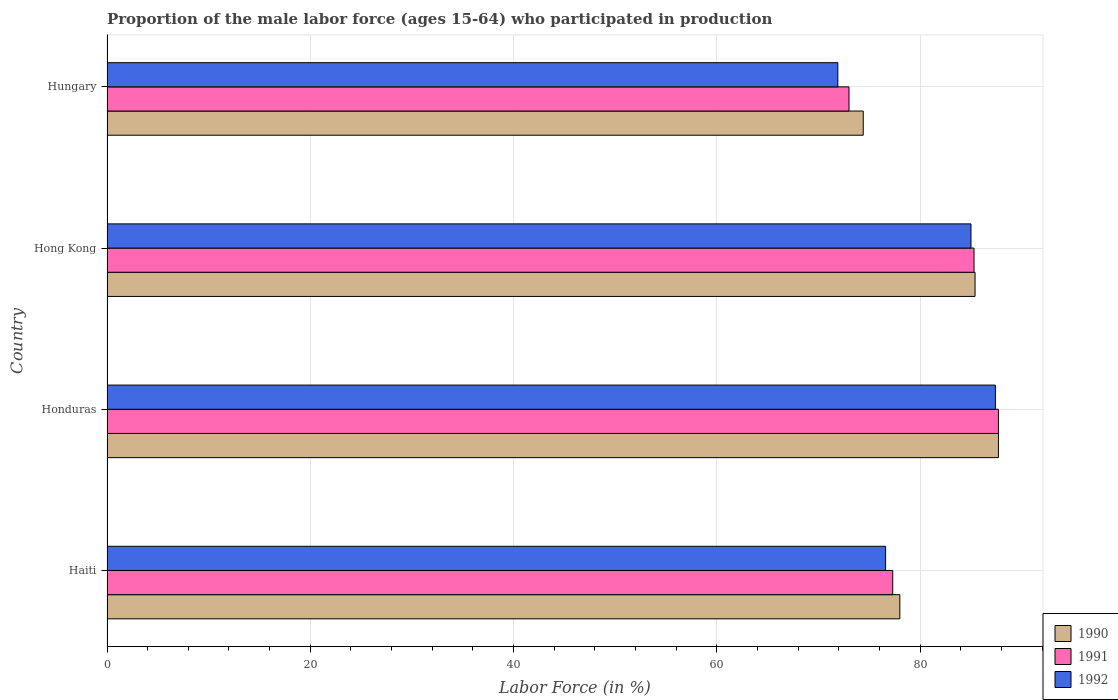How many groups of bars are there?
Your response must be concise. 4. Are the number of bars per tick equal to the number of legend labels?
Make the answer very short. Yes. Are the number of bars on each tick of the Y-axis equal?
Your answer should be compact. Yes. How many bars are there on the 3rd tick from the top?
Give a very brief answer. 3. What is the label of the 2nd group of bars from the top?
Provide a succinct answer. Hong Kong. What is the proportion of the male labor force who participated in production in 1990 in Hungary?
Offer a terse response. 74.4. Across all countries, what is the maximum proportion of the male labor force who participated in production in 1991?
Offer a very short reply. 87.7. Across all countries, what is the minimum proportion of the male labor force who participated in production in 1991?
Provide a short and direct response. 73. In which country was the proportion of the male labor force who participated in production in 1992 maximum?
Your answer should be very brief. Honduras. In which country was the proportion of the male labor force who participated in production in 1990 minimum?
Provide a short and direct response. Hungary. What is the total proportion of the male labor force who participated in production in 1992 in the graph?
Make the answer very short. 320.9. What is the difference between the proportion of the male labor force who participated in production in 1990 in Hong Kong and the proportion of the male labor force who participated in production in 1992 in Haiti?
Ensure brevity in your answer.  8.8. What is the average proportion of the male labor force who participated in production in 1992 per country?
Provide a short and direct response. 80.23. What is the difference between the proportion of the male labor force who participated in production in 1990 and proportion of the male labor force who participated in production in 1992 in Hong Kong?
Provide a succinct answer. 0.4. What is the ratio of the proportion of the male labor force who participated in production in 1990 in Honduras to that in Hungary?
Your answer should be very brief. 1.18. What is the difference between the highest and the second highest proportion of the male labor force who participated in production in 1990?
Provide a short and direct response. 2.3. What is the difference between the highest and the lowest proportion of the male labor force who participated in production in 1992?
Offer a very short reply. 15.5. Is the sum of the proportion of the male labor force who participated in production in 1990 in Haiti and Honduras greater than the maximum proportion of the male labor force who participated in production in 1992 across all countries?
Provide a short and direct response. Yes. How many countries are there in the graph?
Make the answer very short. 4. What is the difference between two consecutive major ticks on the X-axis?
Ensure brevity in your answer.  20. Does the graph contain grids?
Your answer should be compact. Yes. How are the legend labels stacked?
Offer a terse response. Vertical. What is the title of the graph?
Make the answer very short. Proportion of the male labor force (ages 15-64) who participated in production. Does "1961" appear as one of the legend labels in the graph?
Your answer should be compact. No. What is the label or title of the Y-axis?
Make the answer very short. Country. What is the Labor Force (in %) of 1991 in Haiti?
Give a very brief answer. 77.3. What is the Labor Force (in %) in 1992 in Haiti?
Provide a short and direct response. 76.6. What is the Labor Force (in %) in 1990 in Honduras?
Provide a short and direct response. 87.7. What is the Labor Force (in %) in 1991 in Honduras?
Ensure brevity in your answer.  87.7. What is the Labor Force (in %) of 1992 in Honduras?
Your response must be concise. 87.4. What is the Labor Force (in %) of 1990 in Hong Kong?
Offer a terse response. 85.4. What is the Labor Force (in %) in 1991 in Hong Kong?
Ensure brevity in your answer.  85.3. What is the Labor Force (in %) of 1992 in Hong Kong?
Provide a succinct answer. 85. What is the Labor Force (in %) of 1990 in Hungary?
Provide a short and direct response. 74.4. What is the Labor Force (in %) of 1992 in Hungary?
Give a very brief answer. 71.9. Across all countries, what is the maximum Labor Force (in %) of 1990?
Provide a short and direct response. 87.7. Across all countries, what is the maximum Labor Force (in %) in 1991?
Your answer should be very brief. 87.7. Across all countries, what is the maximum Labor Force (in %) in 1992?
Your response must be concise. 87.4. Across all countries, what is the minimum Labor Force (in %) in 1990?
Make the answer very short. 74.4. Across all countries, what is the minimum Labor Force (in %) in 1991?
Offer a terse response. 73. Across all countries, what is the minimum Labor Force (in %) of 1992?
Your answer should be very brief. 71.9. What is the total Labor Force (in %) in 1990 in the graph?
Give a very brief answer. 325.5. What is the total Labor Force (in %) of 1991 in the graph?
Make the answer very short. 323.3. What is the total Labor Force (in %) of 1992 in the graph?
Offer a very short reply. 320.9. What is the difference between the Labor Force (in %) in 1992 in Haiti and that in Honduras?
Your response must be concise. -10.8. What is the difference between the Labor Force (in %) in 1990 in Haiti and that in Hong Kong?
Your response must be concise. -7.4. What is the difference between the Labor Force (in %) of 1991 in Haiti and that in Hong Kong?
Give a very brief answer. -8. What is the difference between the Labor Force (in %) of 1991 in Haiti and that in Hungary?
Provide a short and direct response. 4.3. What is the difference between the Labor Force (in %) in 1992 in Haiti and that in Hungary?
Offer a terse response. 4.7. What is the difference between the Labor Force (in %) of 1990 in Honduras and that in Hong Kong?
Provide a short and direct response. 2.3. What is the difference between the Labor Force (in %) in 1991 in Honduras and that in Hong Kong?
Ensure brevity in your answer.  2.4. What is the difference between the Labor Force (in %) in 1992 in Honduras and that in Hong Kong?
Your answer should be compact. 2.4. What is the difference between the Labor Force (in %) of 1990 in Honduras and that in Hungary?
Keep it short and to the point. 13.3. What is the difference between the Labor Force (in %) in 1991 in Honduras and that in Hungary?
Your response must be concise. 14.7. What is the difference between the Labor Force (in %) of 1990 in Hong Kong and that in Hungary?
Your answer should be very brief. 11. What is the difference between the Labor Force (in %) of 1990 in Haiti and the Labor Force (in %) of 1991 in Honduras?
Give a very brief answer. -9.7. What is the difference between the Labor Force (in %) in 1990 in Haiti and the Labor Force (in %) in 1991 in Hong Kong?
Offer a terse response. -7.3. What is the difference between the Labor Force (in %) in 1990 in Haiti and the Labor Force (in %) in 1992 in Hong Kong?
Ensure brevity in your answer.  -7. What is the difference between the Labor Force (in %) of 1990 in Haiti and the Labor Force (in %) of 1991 in Hungary?
Your response must be concise. 5. What is the difference between the Labor Force (in %) in 1990 in Haiti and the Labor Force (in %) in 1992 in Hungary?
Your answer should be very brief. 6.1. What is the difference between the Labor Force (in %) of 1990 in Honduras and the Labor Force (in %) of 1991 in Hungary?
Your response must be concise. 14.7. What is the difference between the Labor Force (in %) of 1991 in Honduras and the Labor Force (in %) of 1992 in Hungary?
Offer a very short reply. 15.8. What is the difference between the Labor Force (in %) in 1990 in Hong Kong and the Labor Force (in %) in 1991 in Hungary?
Keep it short and to the point. 12.4. What is the average Labor Force (in %) of 1990 per country?
Provide a succinct answer. 81.38. What is the average Labor Force (in %) in 1991 per country?
Provide a succinct answer. 80.83. What is the average Labor Force (in %) of 1992 per country?
Make the answer very short. 80.22. What is the difference between the Labor Force (in %) of 1990 and Labor Force (in %) of 1991 in Haiti?
Your answer should be very brief. 0.7. What is the difference between the Labor Force (in %) in 1991 and Labor Force (in %) in 1992 in Honduras?
Offer a terse response. 0.3. What is the difference between the Labor Force (in %) in 1990 and Labor Force (in %) in 1991 in Hong Kong?
Your answer should be very brief. 0.1. What is the difference between the Labor Force (in %) of 1990 and Labor Force (in %) of 1992 in Hong Kong?
Give a very brief answer. 0.4. What is the difference between the Labor Force (in %) in 1991 and Labor Force (in %) in 1992 in Hong Kong?
Make the answer very short. 0.3. What is the difference between the Labor Force (in %) in 1990 and Labor Force (in %) in 1992 in Hungary?
Your answer should be very brief. 2.5. What is the ratio of the Labor Force (in %) of 1990 in Haiti to that in Honduras?
Provide a short and direct response. 0.89. What is the ratio of the Labor Force (in %) in 1991 in Haiti to that in Honduras?
Keep it short and to the point. 0.88. What is the ratio of the Labor Force (in %) of 1992 in Haiti to that in Honduras?
Provide a short and direct response. 0.88. What is the ratio of the Labor Force (in %) in 1990 in Haiti to that in Hong Kong?
Provide a succinct answer. 0.91. What is the ratio of the Labor Force (in %) in 1991 in Haiti to that in Hong Kong?
Provide a succinct answer. 0.91. What is the ratio of the Labor Force (in %) of 1992 in Haiti to that in Hong Kong?
Provide a short and direct response. 0.9. What is the ratio of the Labor Force (in %) of 1990 in Haiti to that in Hungary?
Your response must be concise. 1.05. What is the ratio of the Labor Force (in %) in 1991 in Haiti to that in Hungary?
Offer a very short reply. 1.06. What is the ratio of the Labor Force (in %) in 1992 in Haiti to that in Hungary?
Provide a short and direct response. 1.07. What is the ratio of the Labor Force (in %) in 1990 in Honduras to that in Hong Kong?
Give a very brief answer. 1.03. What is the ratio of the Labor Force (in %) in 1991 in Honduras to that in Hong Kong?
Provide a succinct answer. 1.03. What is the ratio of the Labor Force (in %) of 1992 in Honduras to that in Hong Kong?
Ensure brevity in your answer.  1.03. What is the ratio of the Labor Force (in %) in 1990 in Honduras to that in Hungary?
Keep it short and to the point. 1.18. What is the ratio of the Labor Force (in %) in 1991 in Honduras to that in Hungary?
Offer a terse response. 1.2. What is the ratio of the Labor Force (in %) of 1992 in Honduras to that in Hungary?
Your answer should be compact. 1.22. What is the ratio of the Labor Force (in %) in 1990 in Hong Kong to that in Hungary?
Ensure brevity in your answer.  1.15. What is the ratio of the Labor Force (in %) of 1991 in Hong Kong to that in Hungary?
Make the answer very short. 1.17. What is the ratio of the Labor Force (in %) of 1992 in Hong Kong to that in Hungary?
Provide a short and direct response. 1.18. What is the difference between the highest and the second highest Labor Force (in %) in 1990?
Provide a short and direct response. 2.3. What is the difference between the highest and the lowest Labor Force (in %) of 1990?
Your response must be concise. 13.3. What is the difference between the highest and the lowest Labor Force (in %) of 1992?
Offer a terse response. 15.5. 